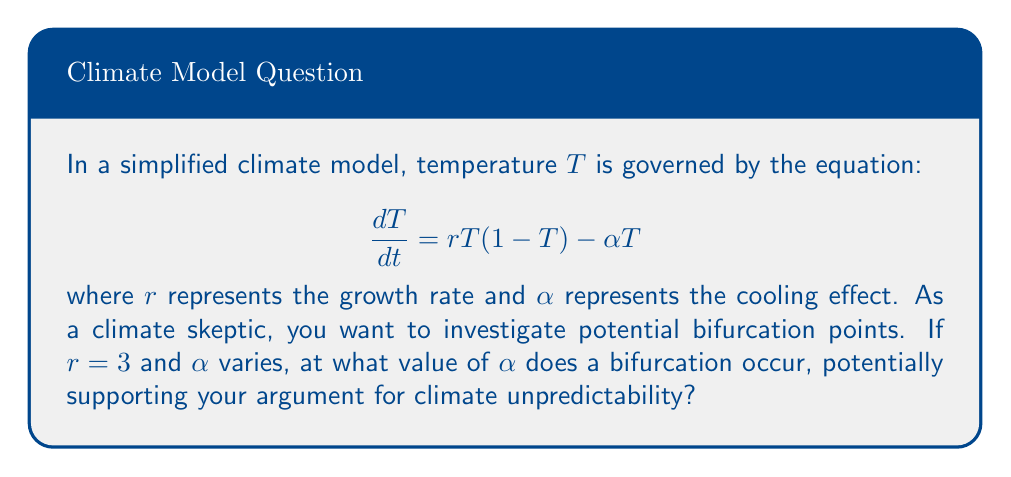Can you answer this question? To find the bifurcation point, we need to follow these steps:

1) First, find the equilibrium points by setting $\frac{dT}{dt} = 0$:
   
   $$rT(1-T) - \alpha T = 0$$
   $$T(r(1-T) - \alpha) = 0$$

2) This gives us two equilibrium points:
   $T_1 = 0$ and $T_2 = 1 - \frac{\alpha}{r}$

3) The bifurcation occurs when these equilibrium points coincide, i.e., when $T_2 = 0$:

   $$1 - \frac{\alpha}{r} = 0$$
   $$\frac{\alpha}{r} = 1$$
   $$\alpha = r$$

4) Given that $r = 3$, the bifurcation occurs when $\alpha = 3$.

5) To verify, we can check the stability of $T_1 = 0$:
   
   $$\frac{d}{dT}(\frac{dT}{dt})|_{T=0} = r - \alpha$$

   When $\alpha < 3$, this is positive, indicating $T_1 = 0$ is unstable.
   When $\alpha > 3$, this is negative, indicating $T_1 = 0$ is stable.
   At $\alpha = 3$, we have a bifurcation point.

This bifurcation point could be used to argue that small changes in parameters can lead to significant changes in climate behavior, potentially supporting a skeptical stance on climate predictability.
Answer: $\alpha = 3$ 